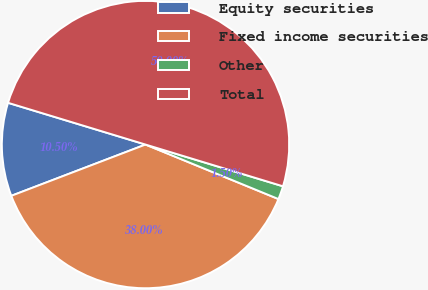Convert chart to OTSL. <chart><loc_0><loc_0><loc_500><loc_500><pie_chart><fcel>Equity securities<fcel>Fixed income securities<fcel>Other<fcel>Total<nl><fcel>10.5%<fcel>38.0%<fcel>1.5%<fcel>50.0%<nl></chart> 